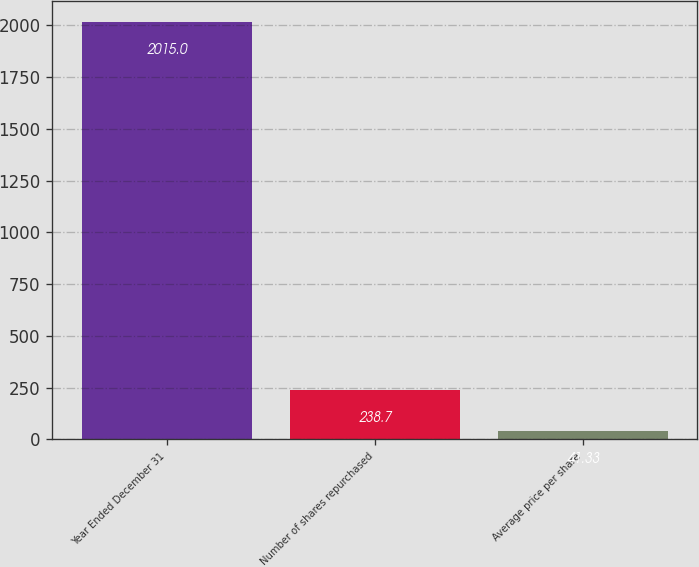Convert chart to OTSL. <chart><loc_0><loc_0><loc_500><loc_500><bar_chart><fcel>Year Ended December 31<fcel>Number of shares repurchased<fcel>Average price per share<nl><fcel>2015<fcel>238.7<fcel>41.33<nl></chart> 